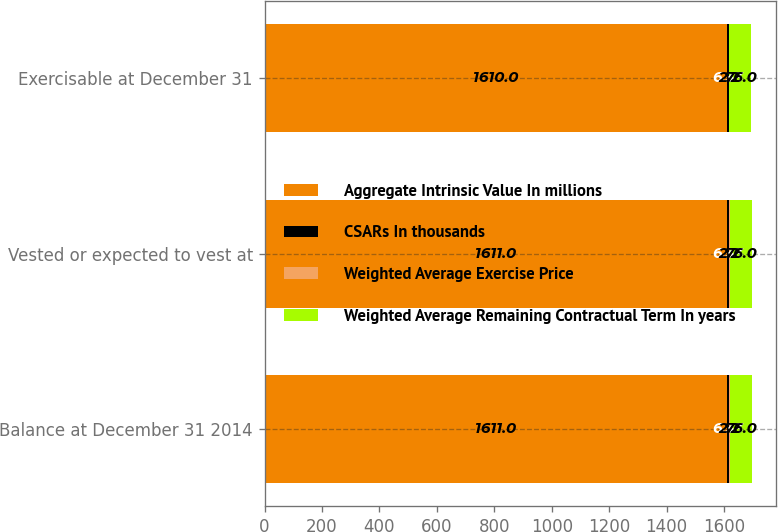Convert chart. <chart><loc_0><loc_0><loc_500><loc_500><stacked_bar_chart><ecel><fcel>Balance at December 31 2014<fcel>Vested or expected to vest at<fcel>Exercisable at December 31<nl><fcel>Aggregate Intrinsic Value In millions<fcel>1611<fcel>1611<fcel>1610<nl><fcel>CSARs In thousands<fcel>6.33<fcel>6.33<fcel>6.33<nl><fcel>Weighted Average Exercise Price<fcel>2.2<fcel>2.2<fcel>2.2<nl><fcel>Weighted Average Remaining Contractual Term In years<fcel>76<fcel>76<fcel>76<nl></chart> 